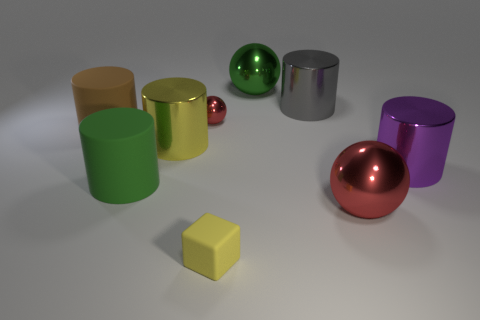Subtract all big brown cylinders. How many cylinders are left? 4 Subtract all blue cylinders. How many red balls are left? 2 Subtract 1 spheres. How many spheres are left? 2 Subtract all cylinders. How many objects are left? 4 Add 1 tiny metallic things. How many tiny metallic things exist? 2 Subtract all purple cylinders. How many cylinders are left? 4 Subtract 1 yellow cubes. How many objects are left? 8 Subtract all red cylinders. Subtract all blue spheres. How many cylinders are left? 5 Subtract all metal objects. Subtract all tiny yellow things. How many objects are left? 2 Add 8 large spheres. How many large spheres are left? 10 